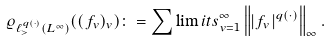<formula> <loc_0><loc_0><loc_500><loc_500>\varrho _ { \ell _ { > } ^ { q ( \cdot ) } ( L ^ { \infty } ) } ( ( f _ { v } ) _ { v } ) \colon = \sum \lim i t s _ { v = 1 } ^ { \infty } \left \| \left | f _ { v } \right | ^ { q ( \cdot ) } \right \| _ { \infty } .</formula> 